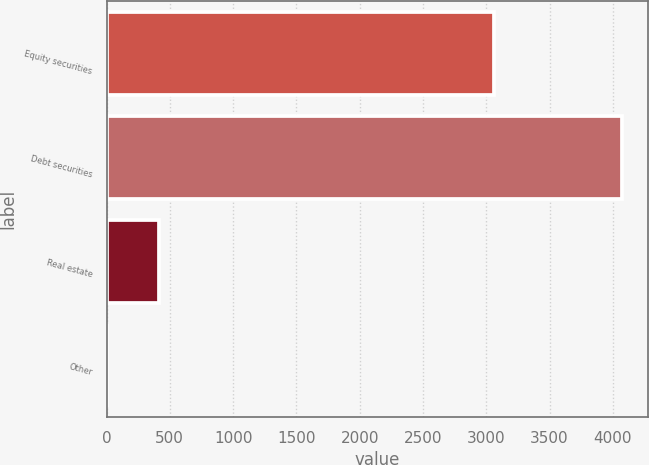<chart> <loc_0><loc_0><loc_500><loc_500><bar_chart><fcel>Equity securities<fcel>Debt securities<fcel>Real estate<fcel>Other<nl><fcel>3060<fcel>4070<fcel>411.5<fcel>5<nl></chart> 